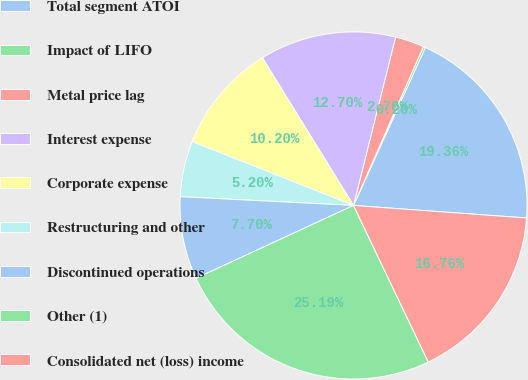<chart> <loc_0><loc_0><loc_500><loc_500><pie_chart><fcel>Total segment ATOI<fcel>Impact of LIFO<fcel>Metal price lag<fcel>Interest expense<fcel>Corporate expense<fcel>Restructuring and other<fcel>Discontinued operations<fcel>Other (1)<fcel>Consolidated net (loss) income<nl><fcel>19.36%<fcel>0.2%<fcel>2.7%<fcel>12.7%<fcel>10.2%<fcel>5.2%<fcel>7.7%<fcel>25.2%<fcel>16.76%<nl></chart> 